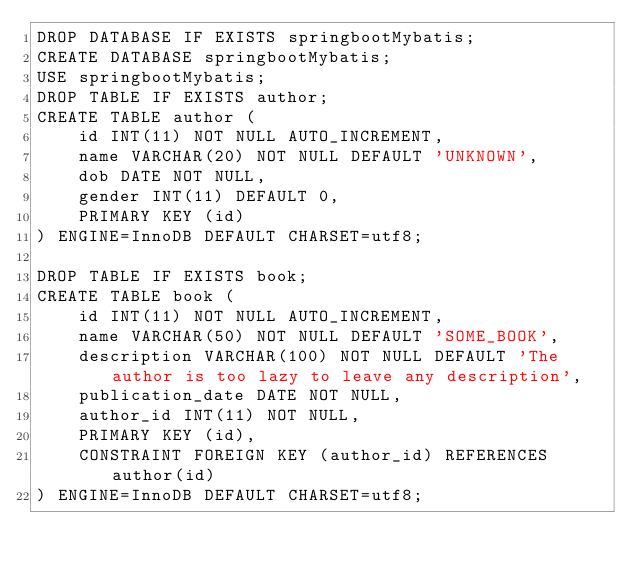Convert code to text. <code><loc_0><loc_0><loc_500><loc_500><_SQL_>DROP DATABASE IF EXISTS springbootMybatis;
CREATE DATABASE springbootMybatis;
USE springbootMybatis;
DROP TABLE IF EXISTS author;
CREATE TABLE author (
    id INT(11) NOT NULL AUTO_INCREMENT,
    name VARCHAR(20) NOT NULL DEFAULT 'UNKNOWN',
    dob DATE NOT NULL,
    gender INT(11) DEFAULT 0,
    PRIMARY KEY (id)
) ENGINE=InnoDB DEFAULT CHARSET=utf8;

DROP TABLE IF EXISTS book;
CREATE TABLE book (
    id INT(11) NOT NULL AUTO_INCREMENT,
    name VARCHAR(50) NOT NULL DEFAULT 'SOME_BOOK',
    description VARCHAR(100) NOT NULL DEFAULT 'The author is too lazy to leave any description',
    publication_date DATE NOT NULL,
    author_id INT(11) NOT NULL,
    PRIMARY KEY (id),
    CONSTRAINT FOREIGN KEY (author_id) REFERENCES author(id)
) ENGINE=InnoDB DEFAULT CHARSET=utf8;</code> 